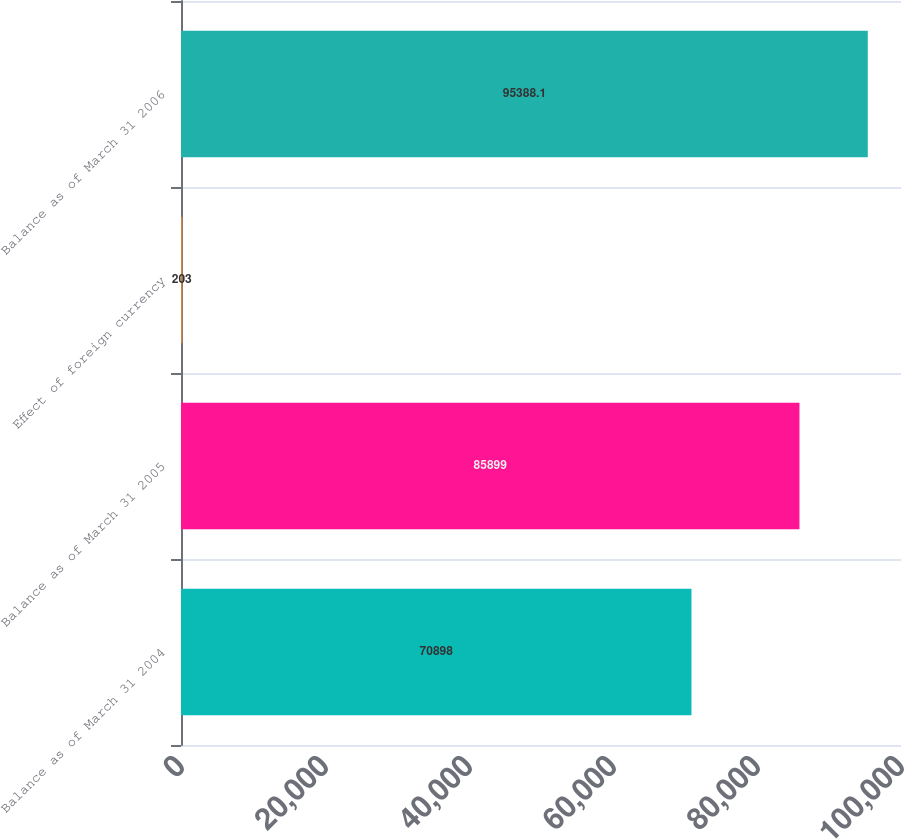<chart> <loc_0><loc_0><loc_500><loc_500><bar_chart><fcel>Balance as of March 31 2004<fcel>Balance as of March 31 2005<fcel>Effect of foreign currency<fcel>Balance as of March 31 2006<nl><fcel>70898<fcel>85899<fcel>203<fcel>95388.1<nl></chart> 